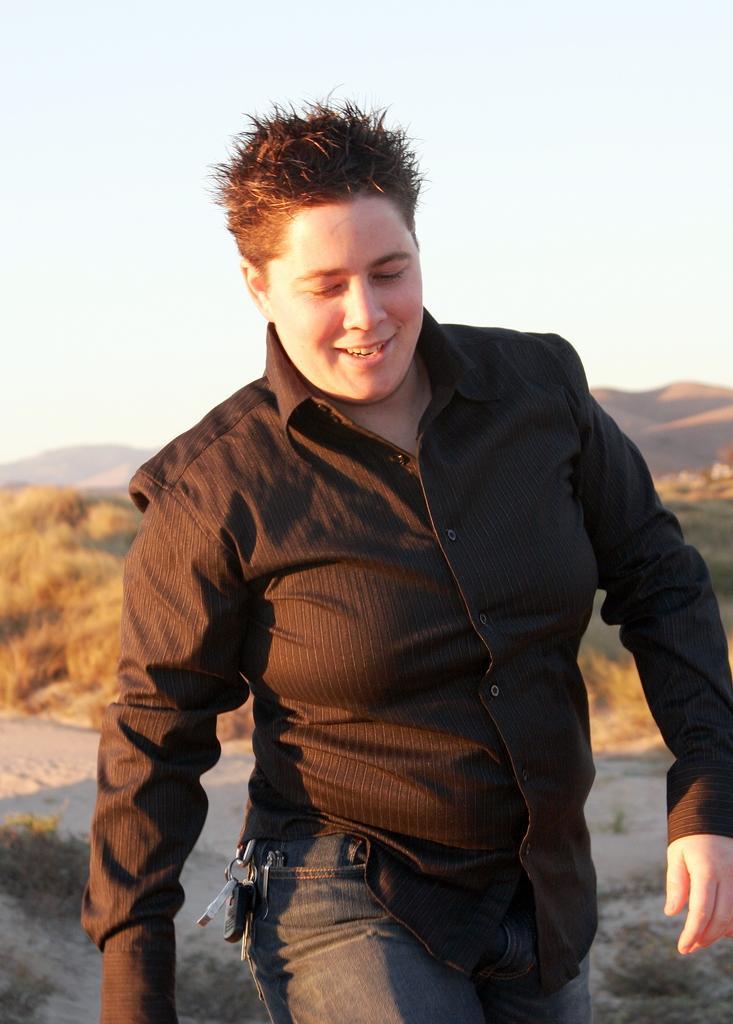Please provide a concise description of this image. In this image we can see a man. In the background there are trees, hills and sky. 